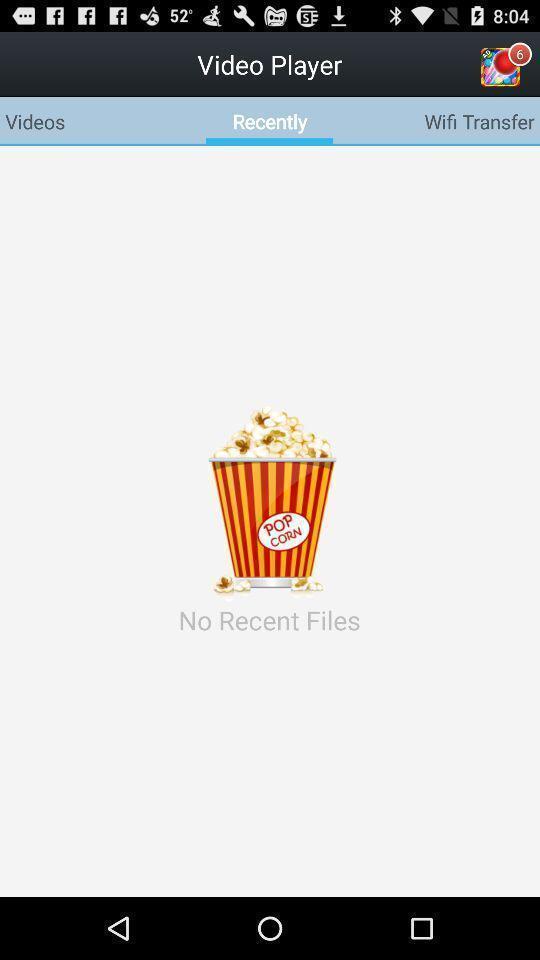Tell me about the visual elements in this screen capture. Recent files status showing in this page. 